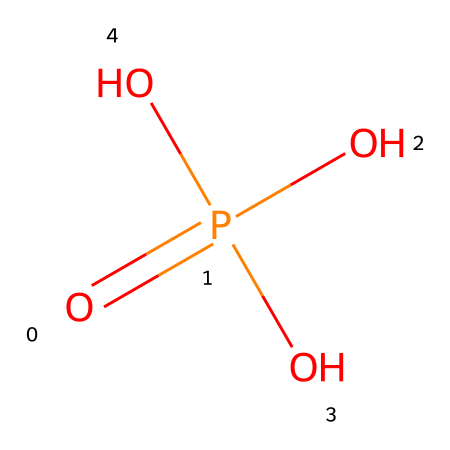How many oxygen atoms are present in this compound? The chemical structure shows that there are four oxygen atoms connected to the phosphorus atom, indicated by the four 'O' symbols in the SMILES representation.
Answer: four What is the central atom in phosphoric acid? In the chemical structure, phosphorus (P) is the atom that forms the core of the molecule, bonded to the four oxygen atoms.
Answer: phosphorus What is the oxidation state of phosphorus in phosphoric acid? To find the oxidation state, consider that each of the three hydroxyl groups (-OH) contributes -1 and the double bond with oxygen contributes -2, leading to phosphorus being +5 overall.
Answer: +5 How many hydrogen atoms are present in this molecule? The structure indicates there are three hydroxyl groups (-OH), and each contributes one hydrogen atom, leading to a total of three hydrogen atoms.
Answer: three What kind of acid is phosphoric acid classified as? Given that it contains three acidic protons, it is classified as a triprotic acid. This is determined by the presence of three -OH groups that can dissociate to release protons.
Answer: triprotic How might phosphoric acid form in Martian clouds? The formation of phosphoric acid in Martian clouds could occur via reactions involving phosphorus oxides and water vapor. Water vapor and phosphorous oxides present in the Martian atmosphere could react under suitable conditions, giving rise to phosphoric acid.
Answer: reactions with water vapor What is the pH range of phosphoric acid solutions? The typical pH of phosphoric acid solutions is around 1 to 3, depending on the concentration; it is a weak acid and thus does not dissociate completely in water.
Answer: 1 to 3 